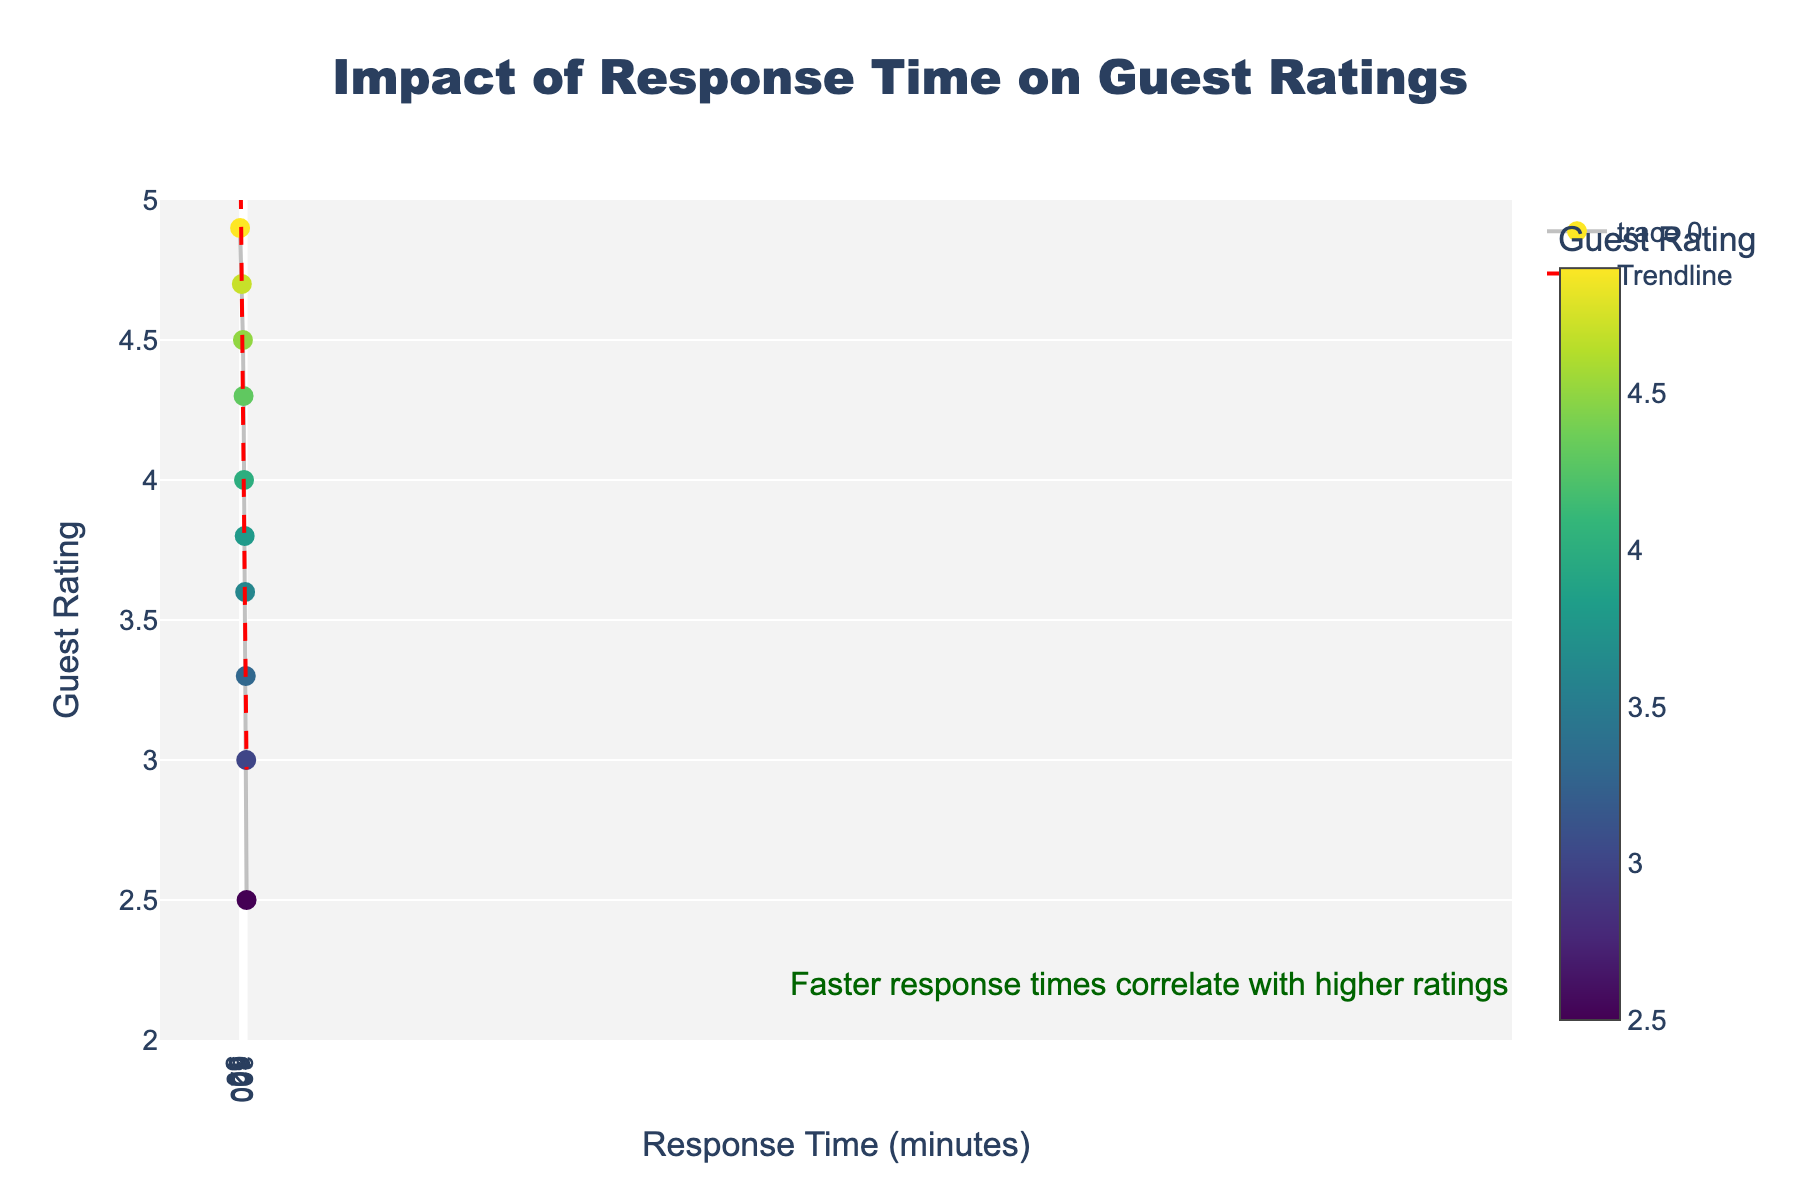What's the title of the figure? The title is displayed at the top of the figure. It reads "Impact of Response Time on Guest Ratings".
Answer: Impact of Response Time on Guest Ratings How many data points are shown in the scatter plot? Viewing the scatter plot, there are 10 markers representing the data points.
Answer: 10 What is the guest rating when the response time is 45 minutes? Locate the marker on the plot at 45 minutes on the x-axis and find the corresponding y-axis value. The marker aligns with a guest rating of 4.3.
Answer: 4.3 What general trend can be observed in the relationship between response time and guest ratings? The line connecting the markers generally slopes downward as the response time increases. This indicates that faster response times are associated with higher guest ratings.
Answer: Faster response times are associated with higher ratings What does the red dashed line represent? The red dashed line is a trendline added to show the general trend of the data points. It illustrates the inverse relationship between response time and guest ratings.
Answer: Trendline Which response time corresponds to the lowest guest rating, and what is that rating? The lowest guest rating is observed at the data point with the highest response time on the x-axis (300 minutes). The guest rating there is 2.5.
Answer: 300 minutes, 2.5 Is guest rating affected more significantly by decreasing response time from 300 to 60 minutes, or from 60 to 30 minutes? From 300 to 60 minutes, the guest rating improves from 2.5 to 4.0, a difference of 1.5. From 60 to 30 minutes, the rating changes from 4.0 to 4.5, a difference of 0.5. The greater improvement occurs from 300 to 60 minutes.
Answer: From 300 to 60 minutes What is the approximate guest rating when the response time is around 10 minutes? Since 10 minutes is not an exact data point, we estimate between 5 and 15 minutes. The guest rating appears to be between 4.9 and 4.7, reasonably around 4.8.
Answer: Approximately 4.8 How does the annotation on the plot interpret the trendline and the scattering of data points? The annotation states, "Faster response times correlate with higher ratings," summarizing that a decrease in response time is linked to an increase in guest ratings as shown by the downward-trending data points and red trendline.
Answer: Faster response times correlate with higher ratings Between response times of 90 and 180 minutes, how much does the guest rating drop? The guest rating drops from 3.8 at 90 minutes to 3.3 at 180 minutes. This is a difference of 3.8 - 3.3 = 0.5.
Answer: 0.5 